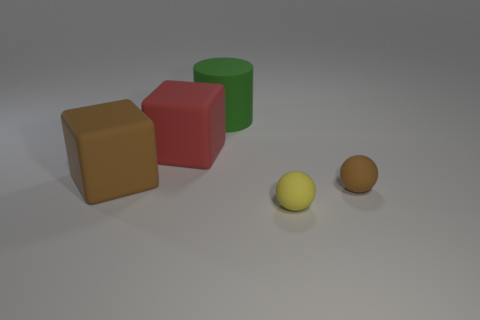What is the color of the other large thing that is the same shape as the large red rubber object?
Provide a succinct answer. Brown. How many small brown rubber balls are on the left side of the thing that is in front of the thing to the right of the small yellow rubber object?
Provide a short and direct response. 0. Is the number of brown rubber blocks greater than the number of red matte spheres?
Your answer should be compact. Yes. Does the brown matte cube have the same size as the brown rubber sphere?
Your answer should be compact. No. How many objects are either big red rubber blocks or large brown rubber objects?
Your response must be concise. 2. The big matte thing that is left of the rubber cube that is to the right of the matte block in front of the large red matte block is what shape?
Keep it short and to the point. Cube. Is the material of the thing that is in front of the tiny brown rubber ball the same as the brown thing that is right of the green thing?
Provide a short and direct response. Yes. What is the material of the red object that is the same shape as the large brown rubber object?
Offer a terse response. Rubber. Are there any other things that have the same size as the red thing?
Make the answer very short. Yes. Do the brown rubber object that is on the right side of the big matte cylinder and the brown thing behind the brown matte sphere have the same shape?
Offer a very short reply. No. 